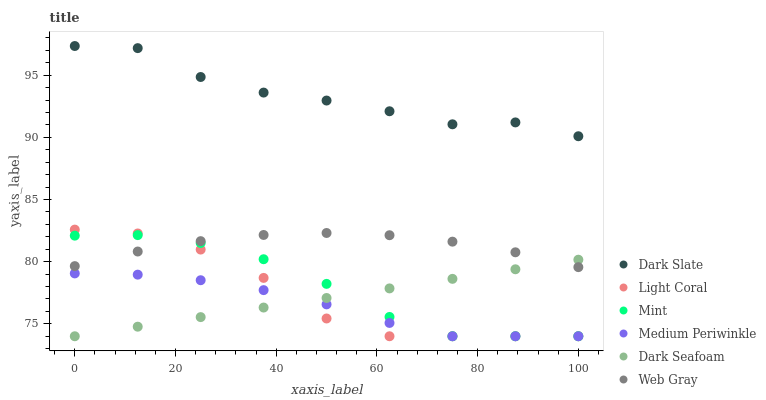Does Medium Periwinkle have the minimum area under the curve?
Answer yes or no. Yes. Does Dark Slate have the maximum area under the curve?
Answer yes or no. Yes. Does Light Coral have the minimum area under the curve?
Answer yes or no. No. Does Light Coral have the maximum area under the curve?
Answer yes or no. No. Is Dark Seafoam the smoothest?
Answer yes or no. Yes. Is Dark Slate the roughest?
Answer yes or no. Yes. Is Medium Periwinkle the smoothest?
Answer yes or no. No. Is Medium Periwinkle the roughest?
Answer yes or no. No. Does Medium Periwinkle have the lowest value?
Answer yes or no. Yes. Does Dark Slate have the lowest value?
Answer yes or no. No. Does Dark Slate have the highest value?
Answer yes or no. Yes. Does Light Coral have the highest value?
Answer yes or no. No. Is Dark Seafoam less than Dark Slate?
Answer yes or no. Yes. Is Dark Slate greater than Mint?
Answer yes or no. Yes. Does Light Coral intersect Dark Seafoam?
Answer yes or no. Yes. Is Light Coral less than Dark Seafoam?
Answer yes or no. No. Is Light Coral greater than Dark Seafoam?
Answer yes or no. No. Does Dark Seafoam intersect Dark Slate?
Answer yes or no. No. 